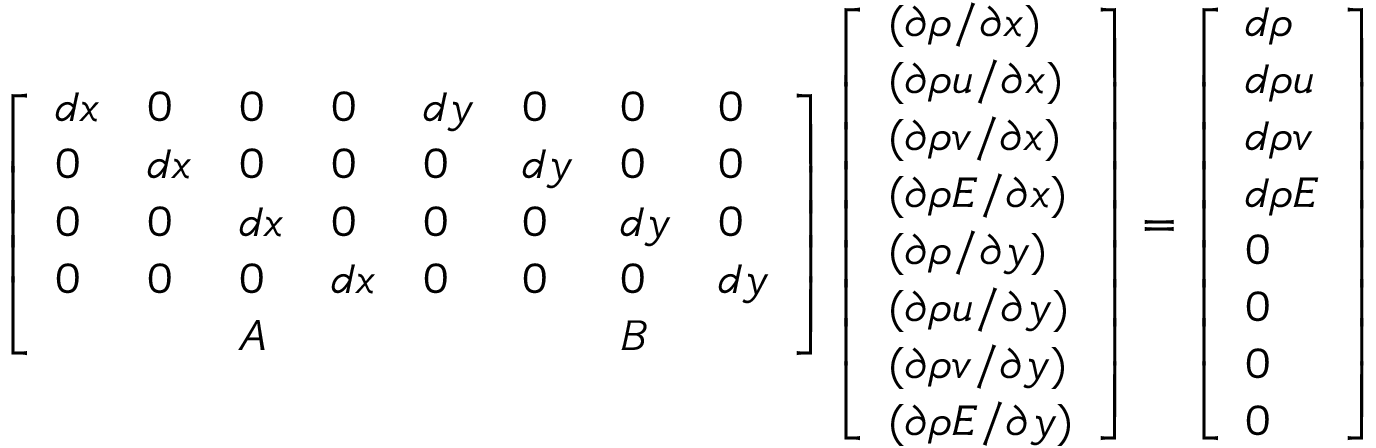Convert formula to latex. <formula><loc_0><loc_0><loc_500><loc_500>\left [ \begin{array} { l l l l l l l l } { d x } & { 0 } & { 0 } & { 0 } & { d y } & { 0 } & { 0 } & { 0 } \\ { 0 } & { d x } & { 0 } & { 0 } & { 0 } & { d y } & { 0 } & { 0 } \\ { 0 } & { 0 } & { d x } & { 0 } & { 0 } & { 0 } & { d y } & { 0 } \\ { 0 } & { 0 } & { 0 } & { d x } & { 0 } & { 0 } & { 0 } & { d y } \\ & & { A } & & & & { B } & \end{array} \right ] \left [ \begin{array} { l } { ( \partial \rho / \partial x ) } \\ { ( \partial \rho u / \partial x ) } \\ { ( \partial \rho v / \partial x ) } \\ { ( \partial \rho E / \partial x ) } \\ { ( \partial \rho / \partial y ) } \\ { ( \partial \rho u / \partial y ) } \\ { ( \partial \rho v / \partial y ) } \\ { ( \partial \rho E / \partial y ) } \end{array} \right ] = \left [ \begin{array} { l } { d \rho } \\ { d \rho u } \\ { d \rho v } \\ { d \rho E } \\ { 0 } \\ { 0 } \\ { 0 } \\ { 0 } \end{array} \right ]</formula> 